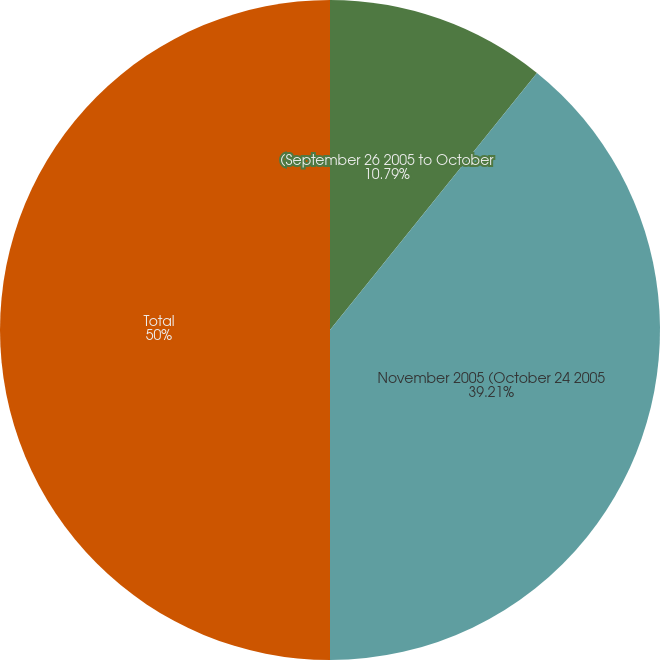Convert chart. <chart><loc_0><loc_0><loc_500><loc_500><pie_chart><fcel>(September 26 2005 to October<fcel>November 2005 (October 24 2005<fcel>Total<nl><fcel>10.79%<fcel>39.21%<fcel>50.0%<nl></chart> 